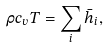Convert formula to latex. <formula><loc_0><loc_0><loc_500><loc_500>\rho c _ { v } T = \sum _ { i } \bar { h } _ { i } ,</formula> 